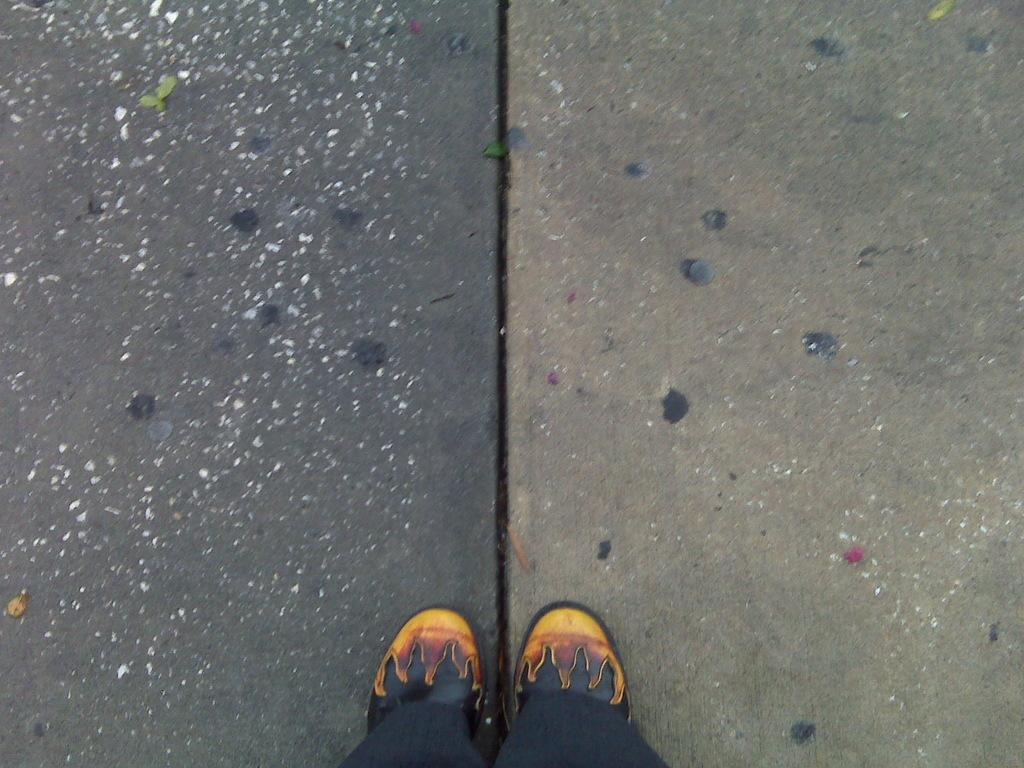What part of a person can be seen in the image? There are legs of a person visible in the image. What type of cable is connected to the side of the box in the image? There is no cable or box present in the image; only the legs of a person are visible. 